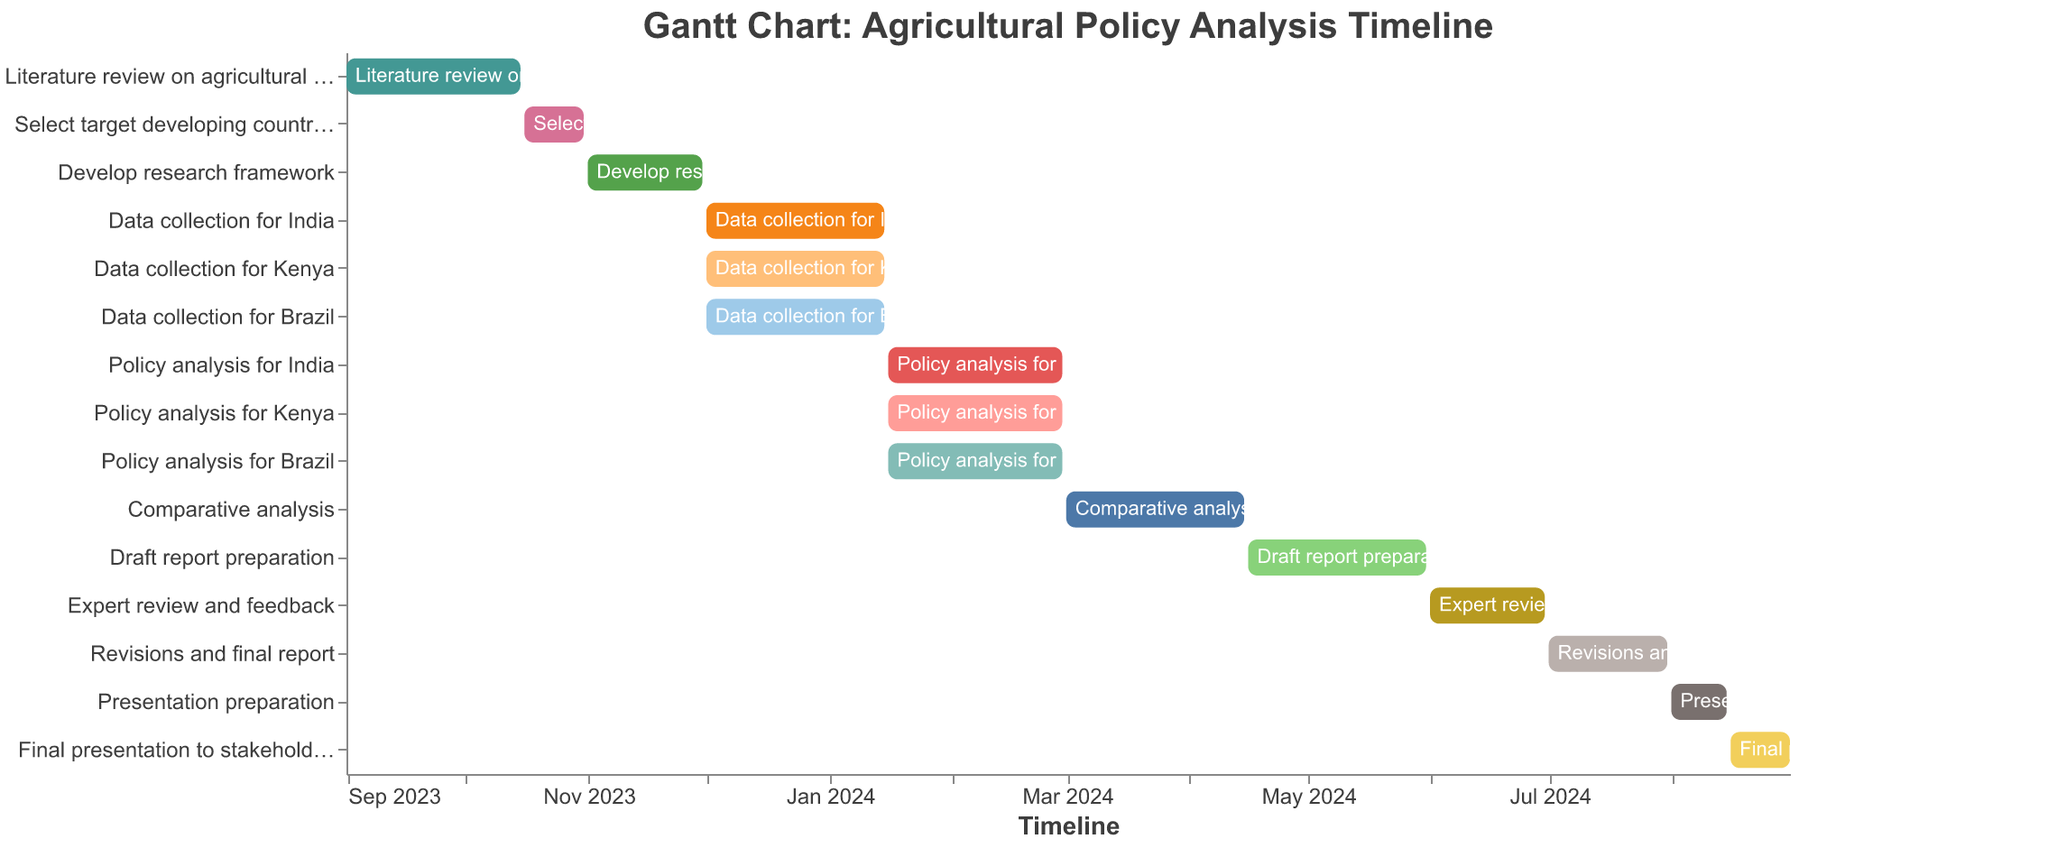When does the literature review on agricultural policies end? The Gantt chart shows the timeline for each task, and the literature review on agricultural policies ends on October 15, 2023.
Answer: October 15, 2023 What is the duration for developing the research framework? To find the duration, calculate the difference between the start date (November 1, 2023) and the end date (November 30, 2023).
Answer: 30 days Which tasks are performed simultaneously with data collection for India? The Gantt chart shows that the data collection for Kenya and Brazil occurs simultaneously with data collection for India, as they share the start (December 1, 2023) and end (January 15, 2024) dates.
Answer: Data collection for Kenya, Data collection for Brazil How many months does the comparative analysis phase take? The comparative analysis phase starts on March 1, 2024, and ends on April 15, 2024. This duration is calculated in days and then converted to months.
Answer: 1.5 months When does the expert review and feedback phase begin? The Gantt chart lists the start date for each task, and the expert review and feedback phase begins on June 1, 2024.
Answer: June 1, 2024 What is the total time allocated for the policy analysis for India? The policy analysis for India starts on January 16, 2024, and ends on February 29, 2024. Calculate the number of days between these dates.
Answer: 45 days Which task follows immediately after the draft report preparation? The task that follows draft report preparation (ends on May 31, 2024) is expert review and feedback, starting on June 1, 2024.
Answer: Expert review and feedback What is the last task listed in the Gantt chart, and when does it end? The last task in the timeline is the final presentation to stakeholders, ending on August 31, 2024.
Answer: Final presentation to stakeholders, August 31, 2024 Which phase takes the longest time to complete? By comparing the start and end dates of each task, the draft report preparation takes the longest, from April 16, 2024, to May 31, 2024, totaling 45 days.
Answer: Draft report preparation 